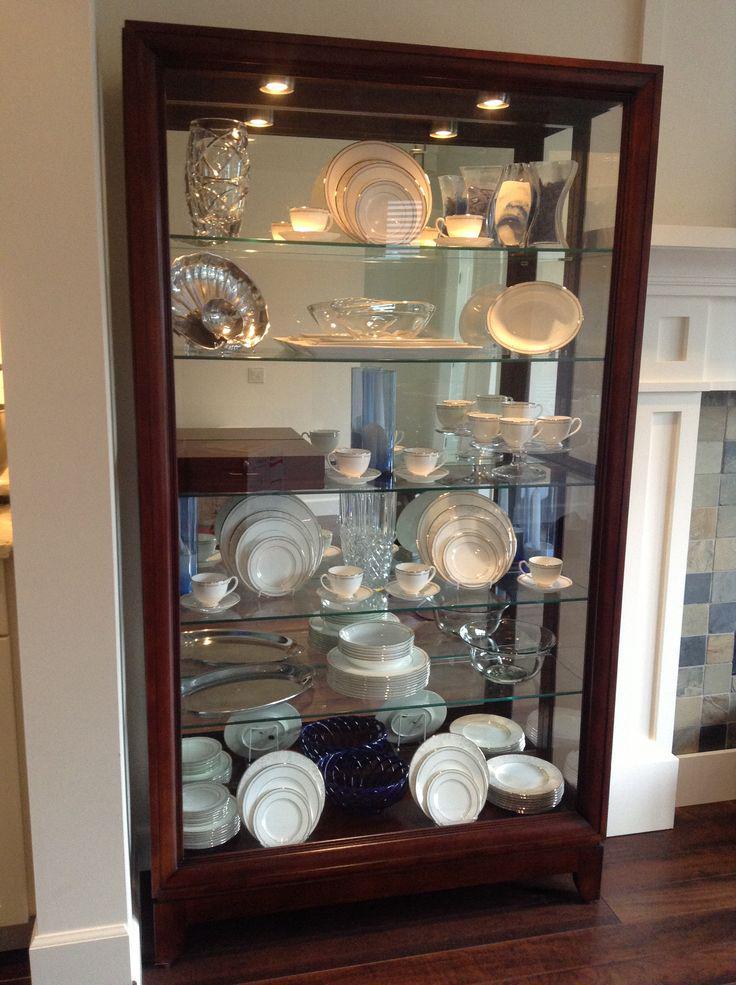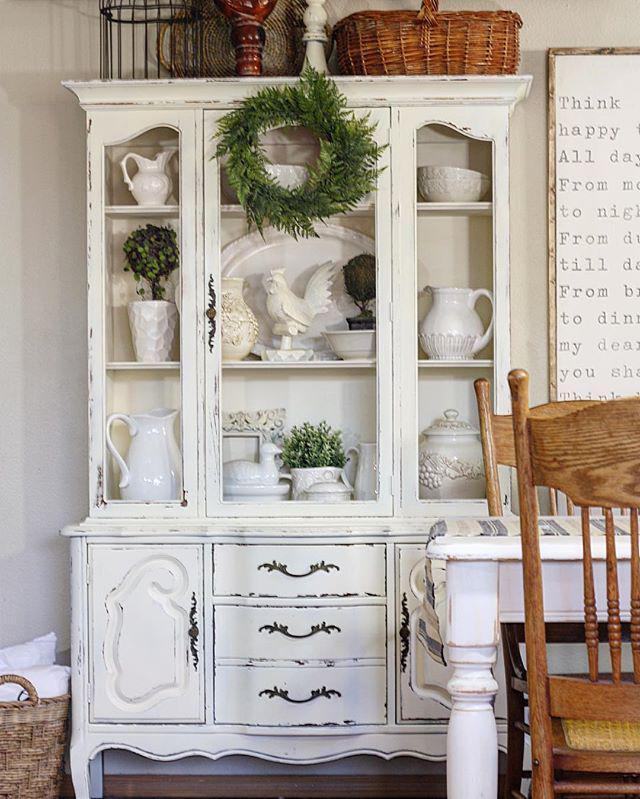The first image is the image on the left, the second image is the image on the right. Evaluate the accuracy of this statement regarding the images: "None of the cabinets are colored red.". Is it true? Answer yes or no. Yes. 